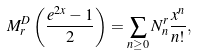<formula> <loc_0><loc_0><loc_500><loc_500>M _ { r } ^ { D } \left ( \frac { e ^ { 2 x } - 1 } { 2 } \right ) = \sum _ { n \geq 0 } N _ { n } ^ { r } \frac { x ^ { n } } { n ! } ,</formula> 